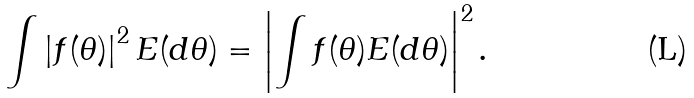Convert formula to latex. <formula><loc_0><loc_0><loc_500><loc_500>\int \left | f ( \theta ) \right | ^ { 2 } E ( d \theta ) = \left | \int f ( \theta ) E ( d \theta ) \right | ^ { 2 } \text {.}</formula> 